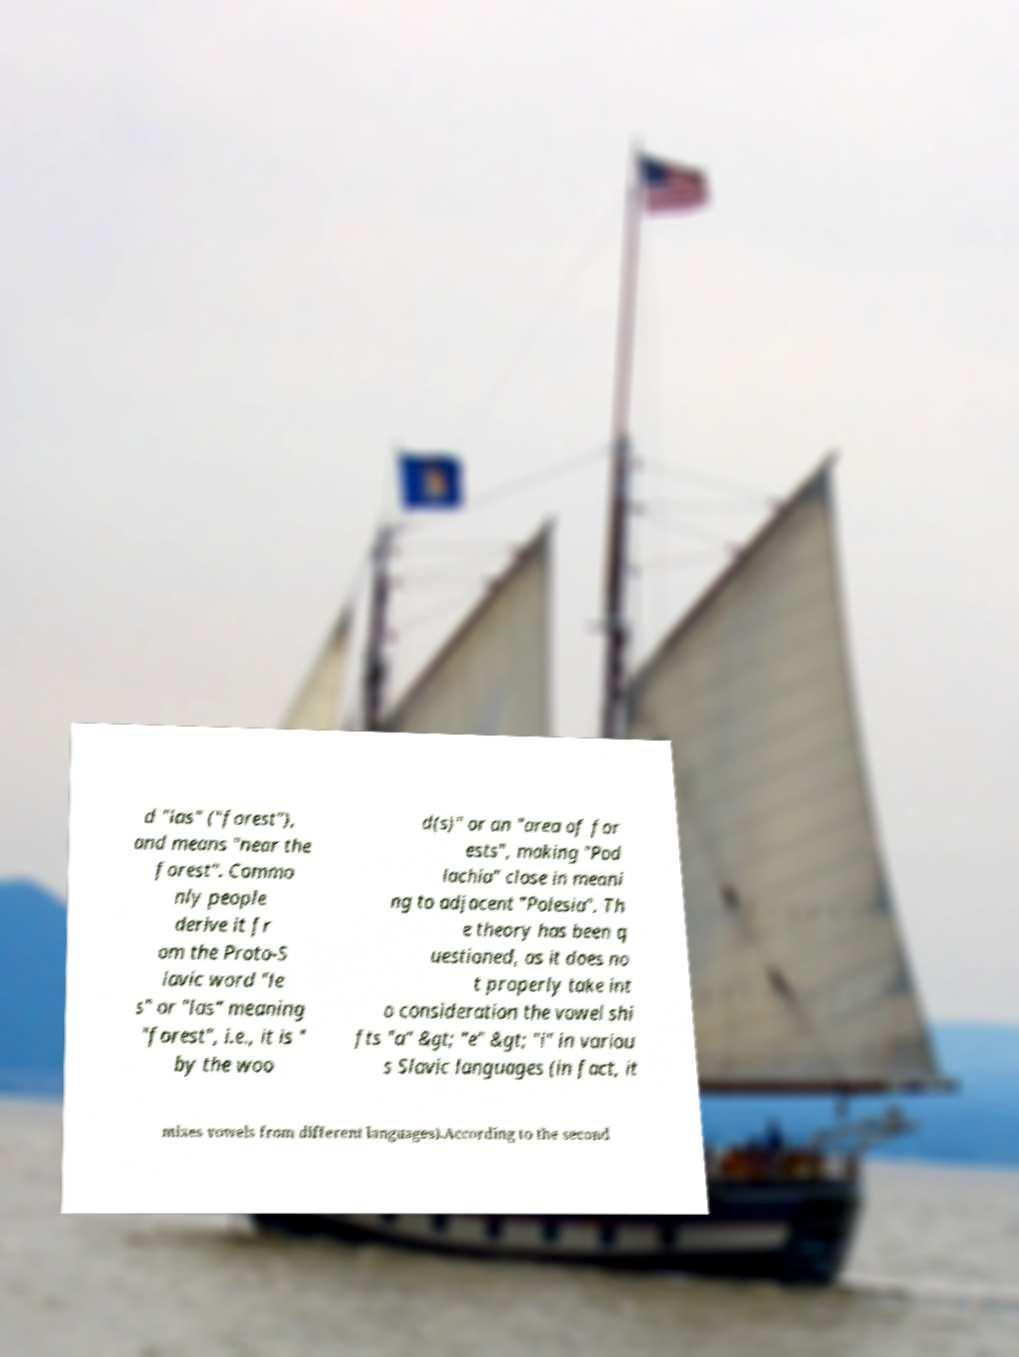Could you extract and type out the text from this image? d "las" ("forest"), and means "near the forest". Commo nly people derive it fr om the Proto-S lavic word "le s" or "las" meaning "forest", i.e., it is " by the woo d(s)" or an "area of for ests", making "Pod lachia" close in meani ng to adjacent "Polesia". Th e theory has been q uestioned, as it does no t properly take int o consideration the vowel shi fts "a" &gt; "e" &gt; "i" in variou s Slavic languages (in fact, it mixes vowels from different languages).According to the second 